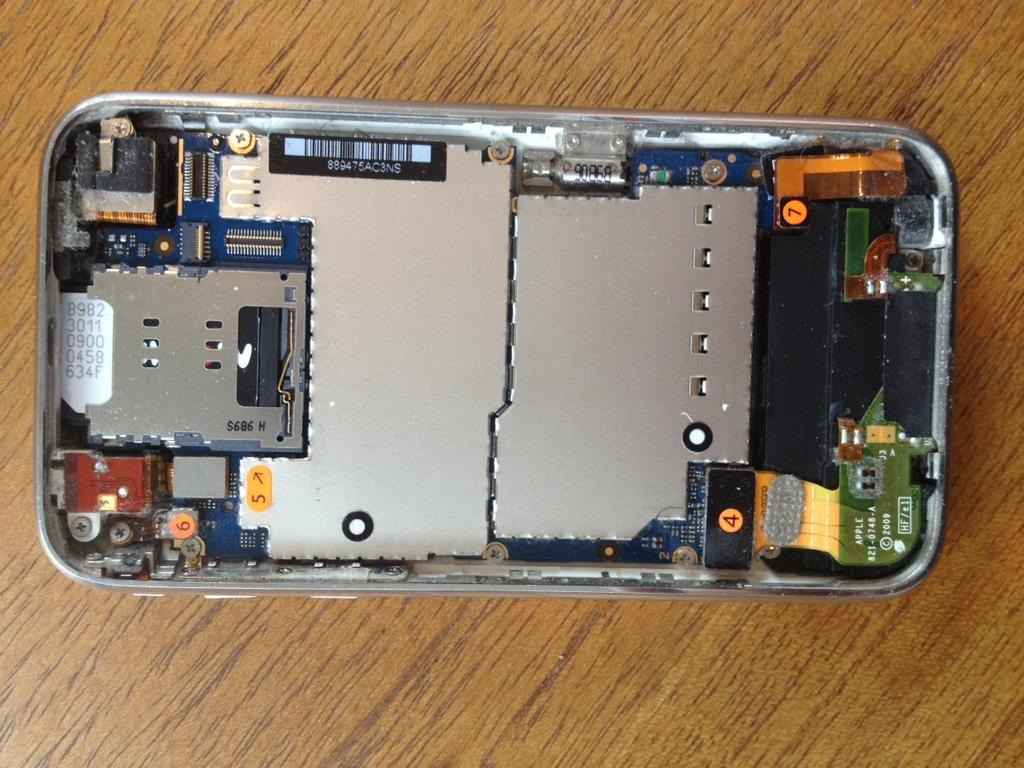Provide a one-sentence caption for the provided image. The back of the phone is removed to show the parts, 4, 5 and 7. 